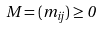Convert formula to latex. <formula><loc_0><loc_0><loc_500><loc_500>M = ( m _ { i j } ) \geq 0</formula> 